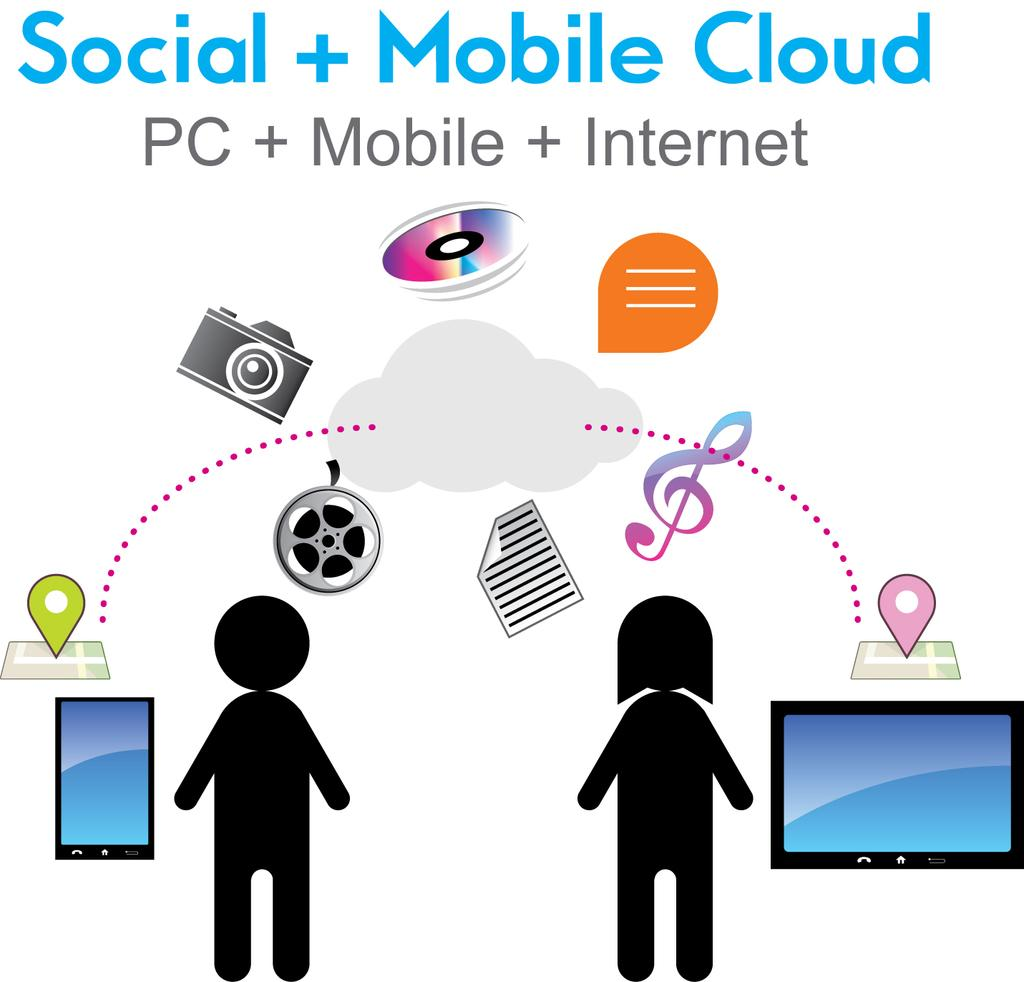What can be found in the image that contains written words? There is text in the image. What else can be found in the image besides text? There are images in the image. Where are the friends sitting in the image? There are no friends present in the image; it only contains text and images. What type of bushes can be seen in the image? There are no bushes present in the image. 